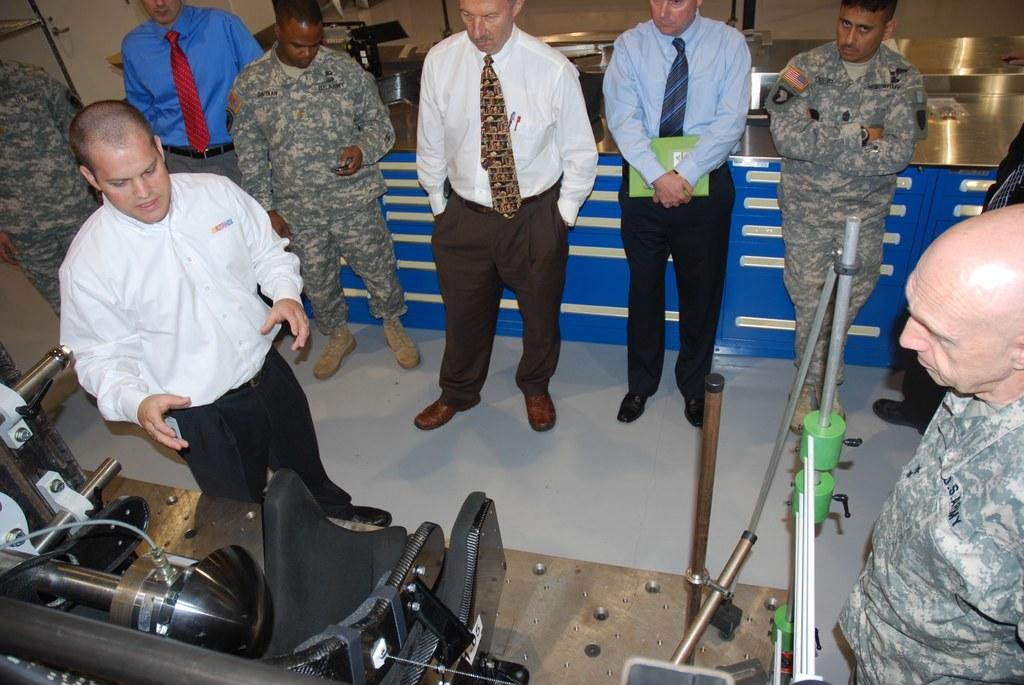Who or what is present in the image? There are people in the image. What is the main object in the image? There is a machine in the image. What are the rods used for in the image? The rods are present in the image, but their purpose is not specified. What can be seen in the background of the image? There is a table and a cupboard in the background of the image. What is on the table in the image? There are things on the table in the image. What type of soda is being served from the machine in the image? There is no mention of soda or a machine serving soda in the image. How many coils are visible on the rods in the image? There is no mention of coils or the number of coils on the rods in the image. 